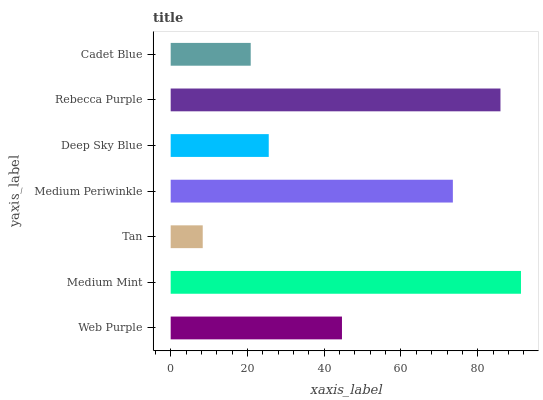Is Tan the minimum?
Answer yes or no. Yes. Is Medium Mint the maximum?
Answer yes or no. Yes. Is Medium Mint the minimum?
Answer yes or no. No. Is Tan the maximum?
Answer yes or no. No. Is Medium Mint greater than Tan?
Answer yes or no. Yes. Is Tan less than Medium Mint?
Answer yes or no. Yes. Is Tan greater than Medium Mint?
Answer yes or no. No. Is Medium Mint less than Tan?
Answer yes or no. No. Is Web Purple the high median?
Answer yes or no. Yes. Is Web Purple the low median?
Answer yes or no. Yes. Is Cadet Blue the high median?
Answer yes or no. No. Is Tan the low median?
Answer yes or no. No. 